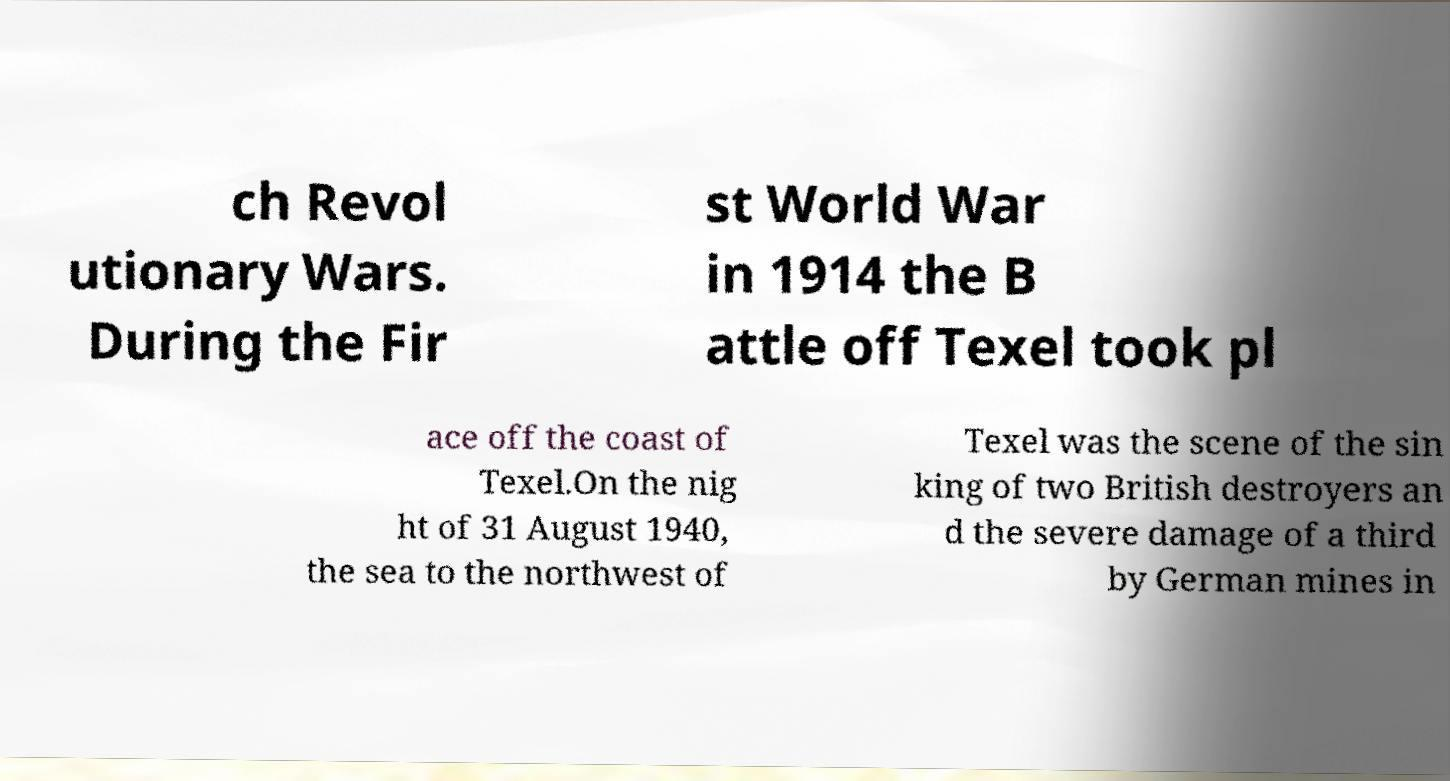I need the written content from this picture converted into text. Can you do that? ch Revol utionary Wars. During the Fir st World War in 1914 the B attle off Texel took pl ace off the coast of Texel.On the nig ht of 31 August 1940, the sea to the northwest of Texel was the scene of the sin king of two British destroyers an d the severe damage of a third by German mines in 